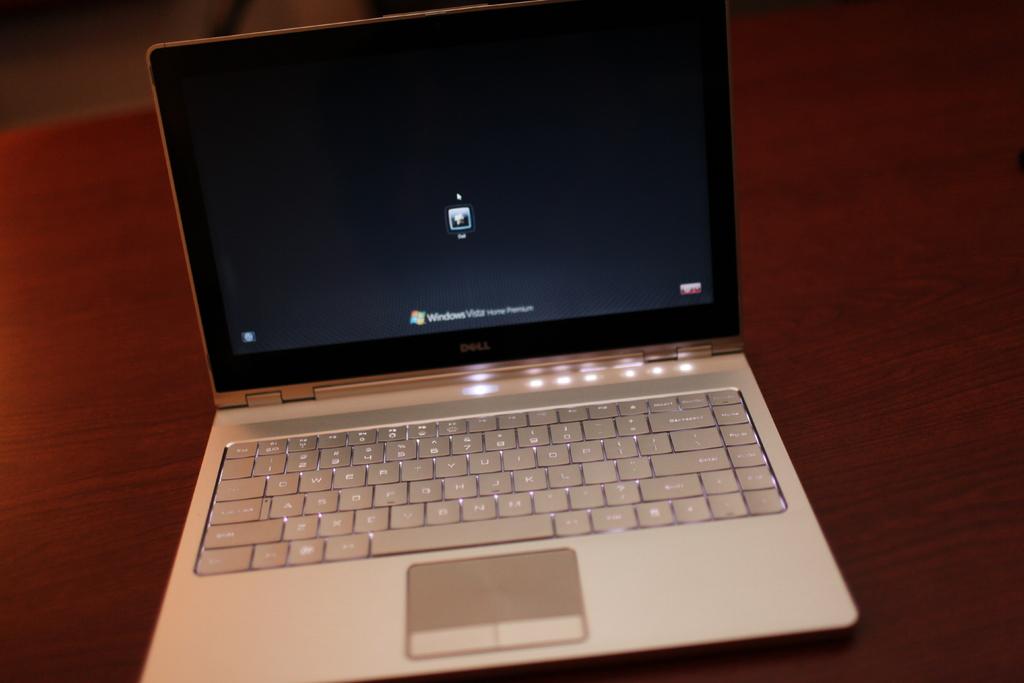What operating system is this?
Your answer should be compact. Windows. 